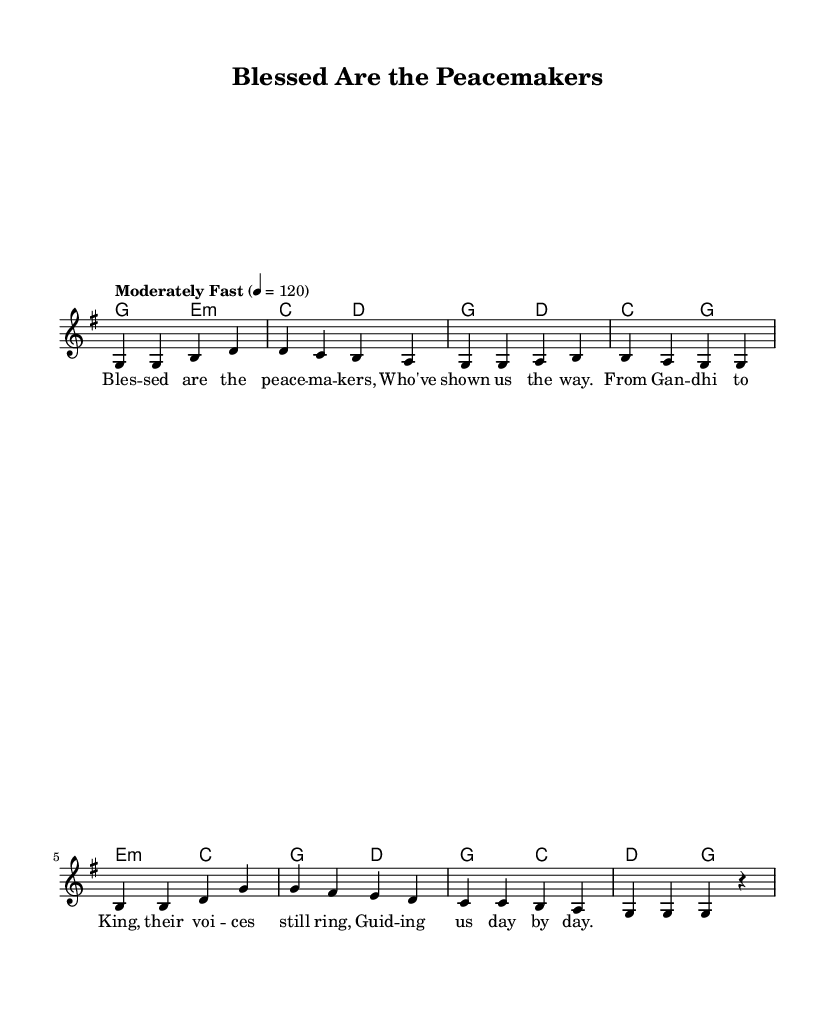What is the key signature of this music? The key signature is G major, which contains one sharp (F#). This information can be found in the global directive of the sheet music.
Answer: G major What is the time signature of the music? The time signature is 4/4, indicated in the global section of the music sheet. This means there are four beats in each measure and a quarter note gets one beat.
Answer: 4/4 What is the tempo marking given for the piece? The tempo marking is "Moderately Fast" with a metronome marking of 120 quarter notes per minute, found in the global directive section of the music.
Answer: Moderately Fast How many lines are in the melody? The melody has eight lines, as seen by counting the phrases in the melody section (each measure corresponds to a line in this case).
Answer: Eight What historical figures are referenced in the lyrics? The lyrics mention Gandhi and King, who are known for their contributions to peace. The names of these figures appear explicitly in the lyric section.
Answer: Gandhi and King What is the main theme of the hymn? The main theme of the hymn is peace, as indicated by the title "Blessed Are the Peacemakers" and the lyrics that celebrate peacemakers throughout history. The overall sentiment conveys a message of guidance and hope for peace.
Answer: Peace What musical mode is used in the harmonies? The harmonies utilize a chord mode structure, specifically starting with a G major chord followed by an E minor chord. This suggests a focus on major and minor tonalities typical in gospel hymns.
Answer: Chord mode 